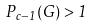<formula> <loc_0><loc_0><loc_500><loc_500>P _ { c - 1 } ( G ) > 1</formula> 